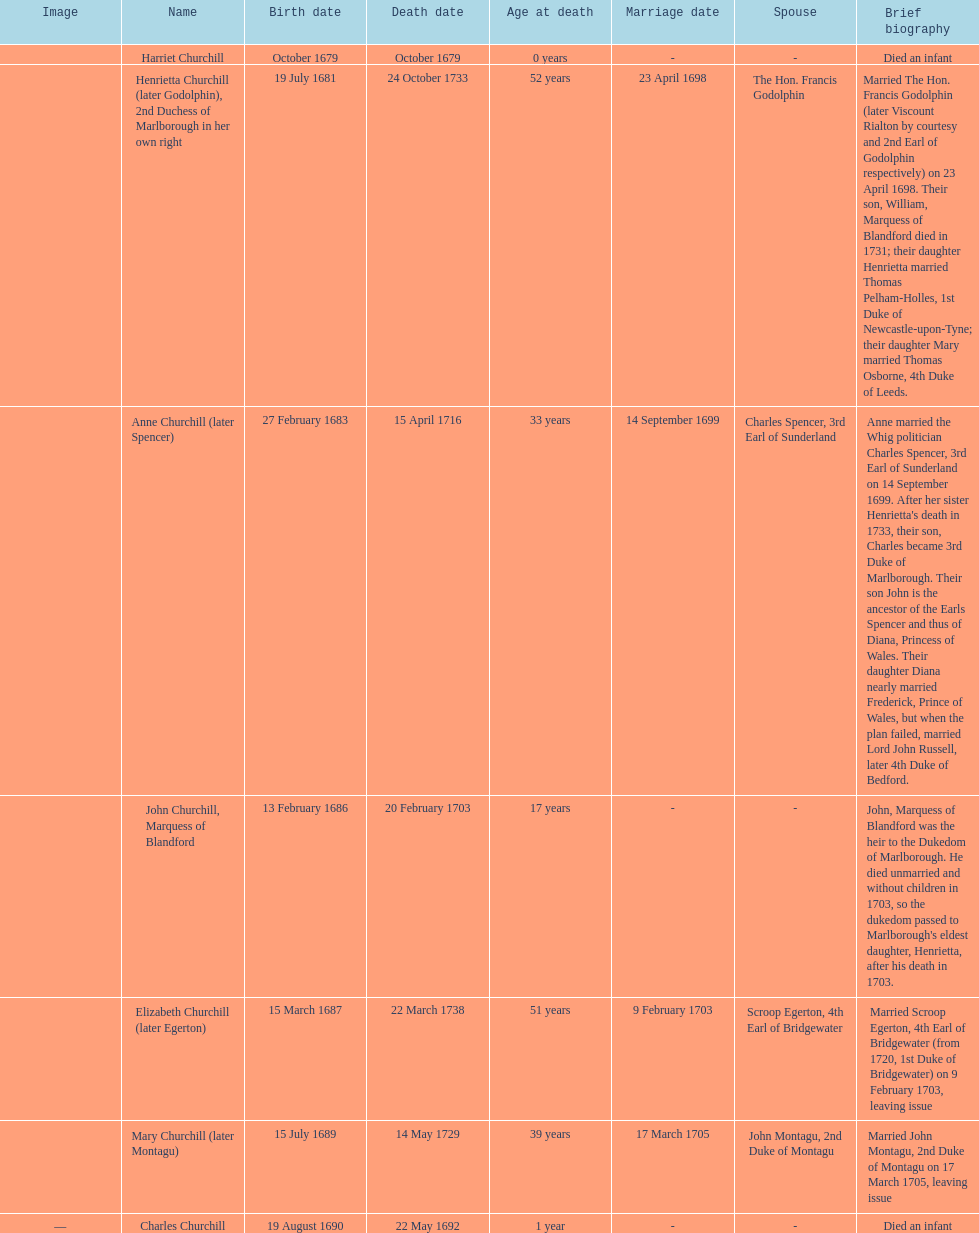How many children were born in february? 2. 